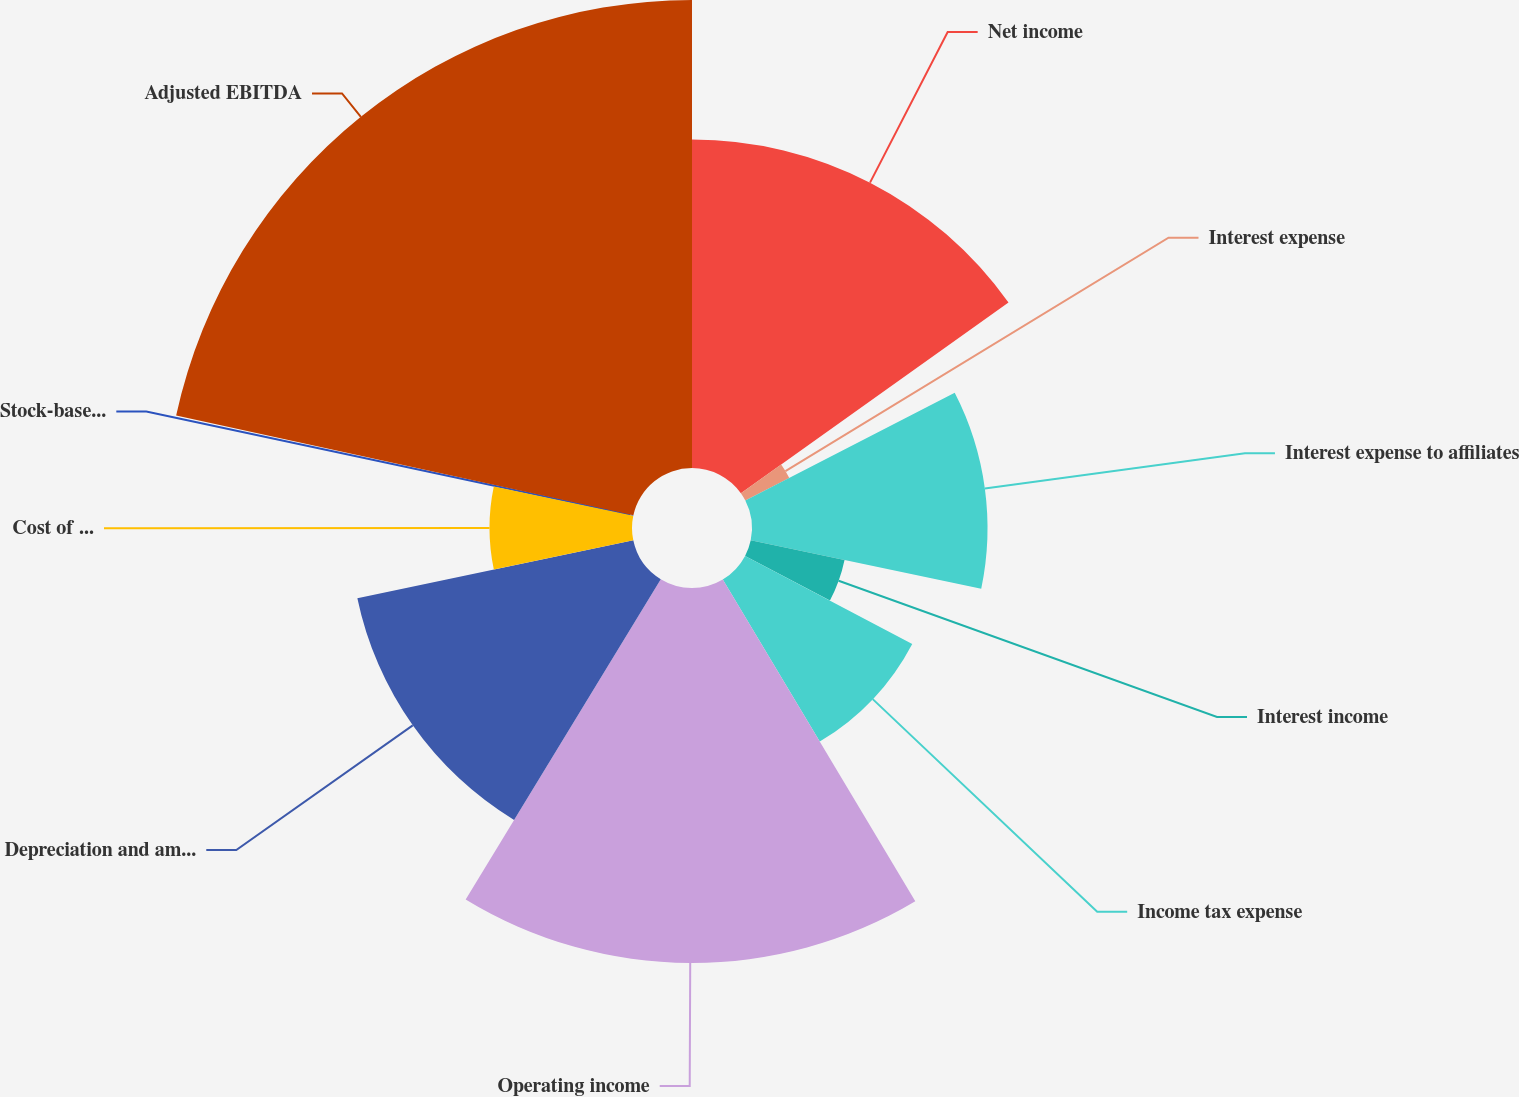Convert chart. <chart><loc_0><loc_0><loc_500><loc_500><pie_chart><fcel>Net income<fcel>Interest expense<fcel>Interest expense to affiliates<fcel>Interest income<fcel>Income tax expense<fcel>Operating income<fcel>Depreciation and amortization<fcel>Cost of MetroPCS business<fcel>Stock-based compensation (1)<fcel>Adjusted EBITDA<nl><fcel>15.15%<fcel>2.28%<fcel>10.86%<fcel>4.42%<fcel>8.71%<fcel>17.29%<fcel>13.0%<fcel>6.57%<fcel>0.14%<fcel>21.58%<nl></chart> 